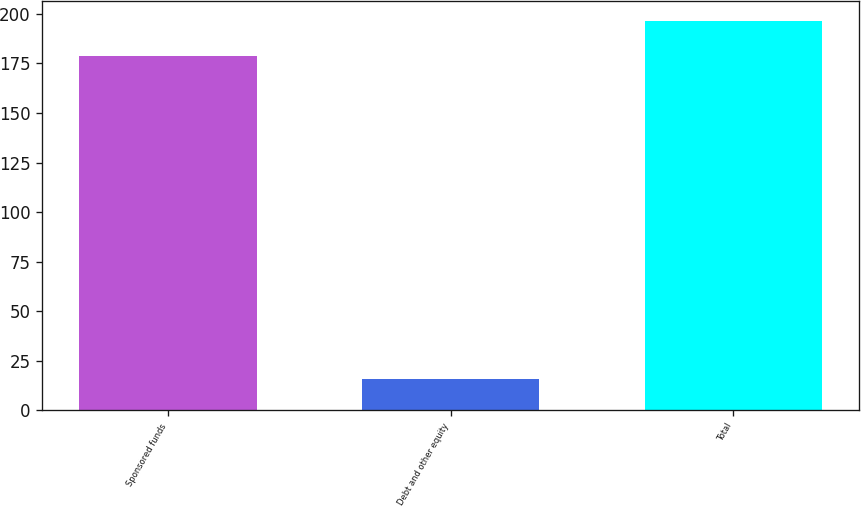<chart> <loc_0><loc_0><loc_500><loc_500><bar_chart><fcel>Sponsored funds<fcel>Debt and other equity<fcel>Total<nl><fcel>178.6<fcel>15.5<fcel>196.46<nl></chart> 